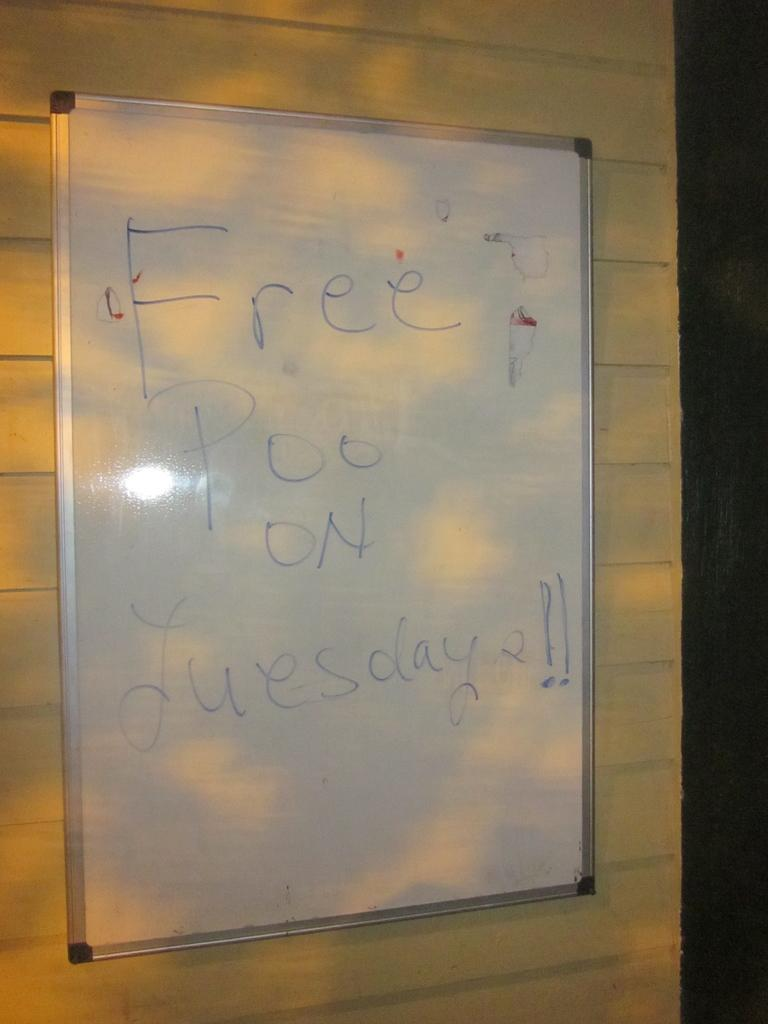<image>
Write a terse but informative summary of the picture. A whiteboard is advertising "free poo on Tuesdays". 